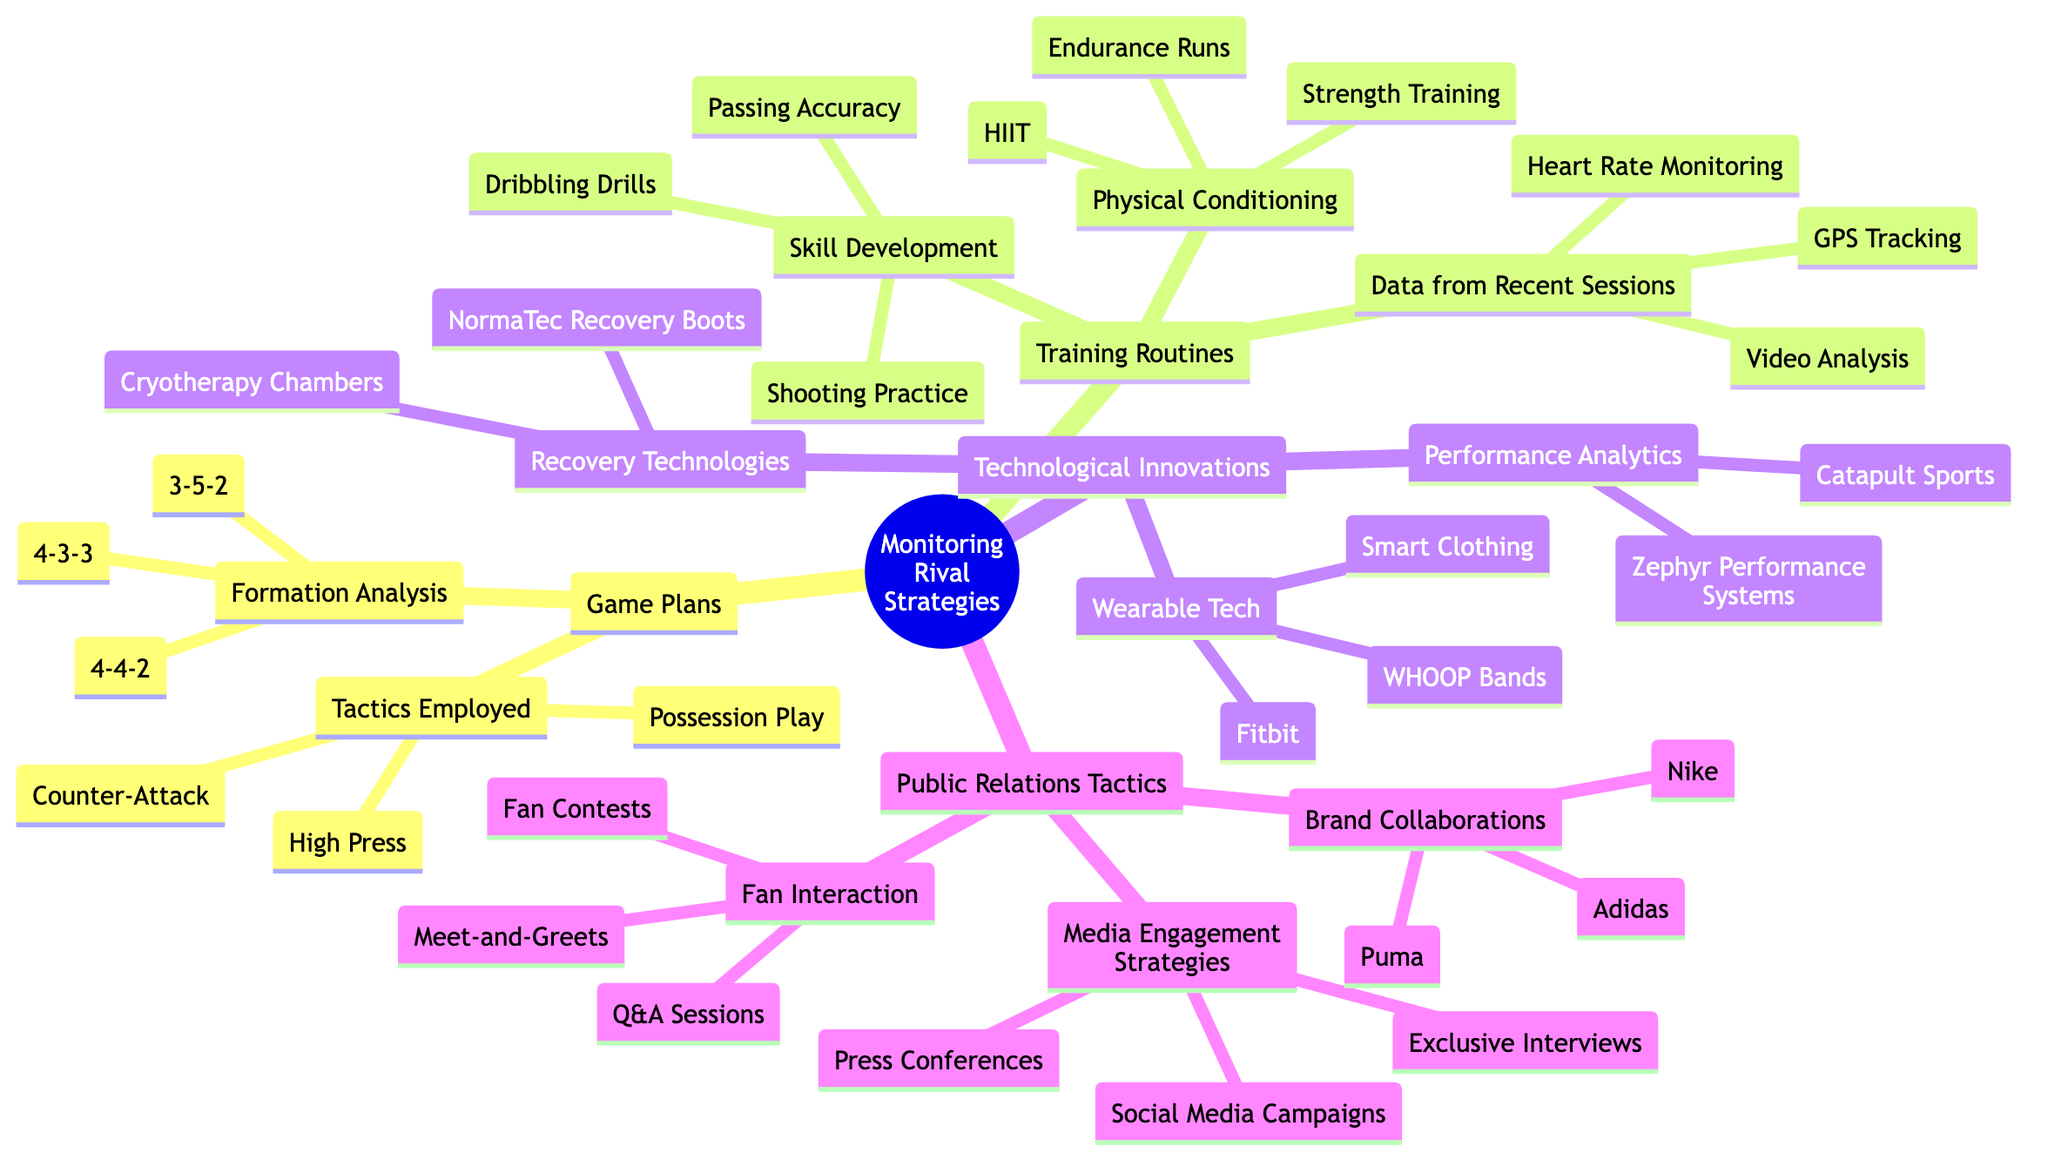What are the three formations analyzed under Game Plans? The diagram lists three formations: 4-4-2, 4-3-3, and 3-5-2 under the "Formation Analysis" node, making them the answer to this question.
Answer: 4-4-2, 4-3-3, 3-5-2 How many technologies are listed under Technological Innovations? The "Technological Innovations" node has three main branches: Performance Analytics, Recovery Technologies, and Wearable Tech, yielding a total of three distinct technological categories.
Answer: 3 Which training routine focuses on endurance? The "Endurance Runs" listed under "Physical Conditioning" relates directly to enhancing endurance, answering the question about the specific routine for this focus.
Answer: Endurance Runs What are the types of media engagement strategies mentioned? There are three types of strategies listed under "Media Engagement Strategies": Press Conferences, Exclusive Interviews, and Social Media Campaigns, which are the answer to the question regarding the strategies.
Answer: Press Conferences, Exclusive Interviews, Social Media Campaigns Which company is mentioned first under Brand Collaborations? The diagram lists Nike, Adidas, and Puma under "Brand Collaborations," with Nike being the first company mentioned, thus directly answering the query about order.
Answer: Nike What training method uses heart rate monitoring? Under "Data from Recent Sessions," "Heart Rate Monitoring" is specifically mentioned as a method utilized, providing a straightforward answer to the question regarding training routines.
Answer: Heart Rate Monitoring Which wearable tech is referenced that tracks fitness? "Fitbit" is explicitly listed under "Wearable Tech," serving as the answer to the inquiry about fitness tracking devices.
Answer: Fitbit What type of tactic utilizes High Press? The "High Press" is listed under "Tactics Employed," which falls under the broader category of Game Plans, linking it directly to the type of tactic utilized.
Answer: Game Plans How many different skill development activities are identified? Under "Skill Development," three activities are outlined: Dribbling Drills, Shooting Practice, and Passing Accuracy, thus providing a total count of skill development activities mentioned.
Answer: 3 